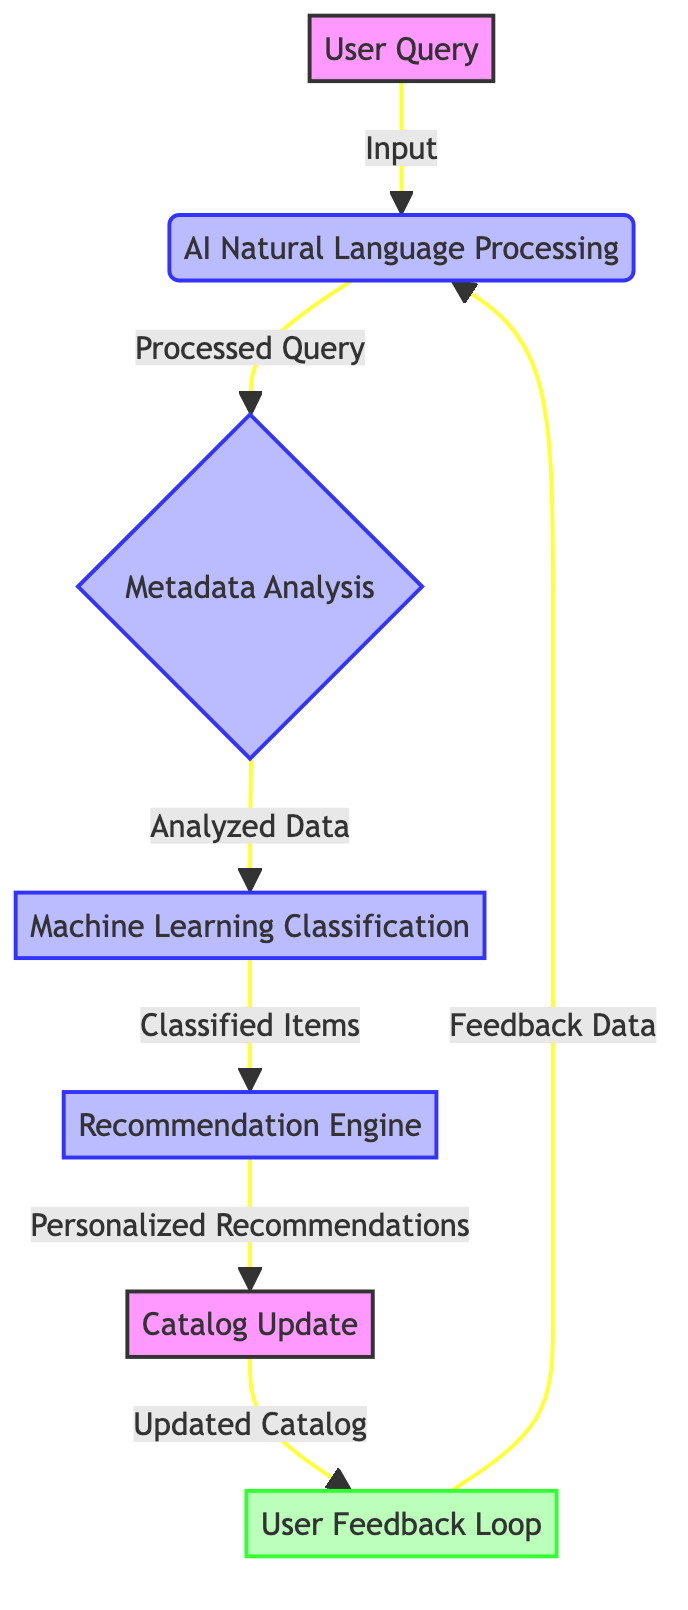What is the first element in the flow chart? The first element shown in the flow chart is the "User Query," which represents the initial user input to request information from the library catalog.
Answer: User Query How many main processes are in the diagram? The diagram contains four distinct processes labeled as AI Natural Language Processing, Metadata Analysis, Machine Learning Classification, and Recommendation Engine, which are the main steps taken after user input.
Answer: 4 What links the "User Feedback Loop" back to the "AI Natural Language Processing"? The arrow labeled "Feedback Data" indicates that feedback from users is utilized to refine and enhance the understanding of user queries processed in the AI Natural Language Processing step.
Answer: Feedback Data What happens after the "Recommendation Engine"? The next step that follows the Recommendation Engine is the Catalog Update, signifying that after personalized recommendations are provided, the catalog is updated based on those changes.
Answer: Catalog Update What type of data does the "User Feedback Loop" collect? The User Feedback Loop is focused on collecting user feedback, which is utilized to enhance AI models and improve catalog accuracy further.
Answer: User feedback What is the purpose of "Machine Learning Classification"? Machine Learning Classification is aimed at classifying library items into appropriate categories using machine learning algorithms, streamlining the organization of cataloged materials.
Answer: Classifying library items Which process receives input directly from the "Metadata Analysis"? The output from the Metadata Analysis, identified as "Analyzed Data," flows directly into the next process known as Machine Learning Classification, which categorizes the analyzed data.
Answer: Machine Learning Classification How does the flow chart illustrate feedback incorporation? The User Feedback Loop collects feedback data which subsequently loops back to the AI Natural Language Processing process, ensuring continuous improvement in understanding user queries.
Answer: User Feedback Loop What is the relationship between "Recommendation Engine" and "Catalog Update"? The Recommendation Engine provides personalized recommendations, which lead to an action represented by the Catalog Update, indicating that recommended items are then updated into the library's catalog.
Answer: Catalog Update 